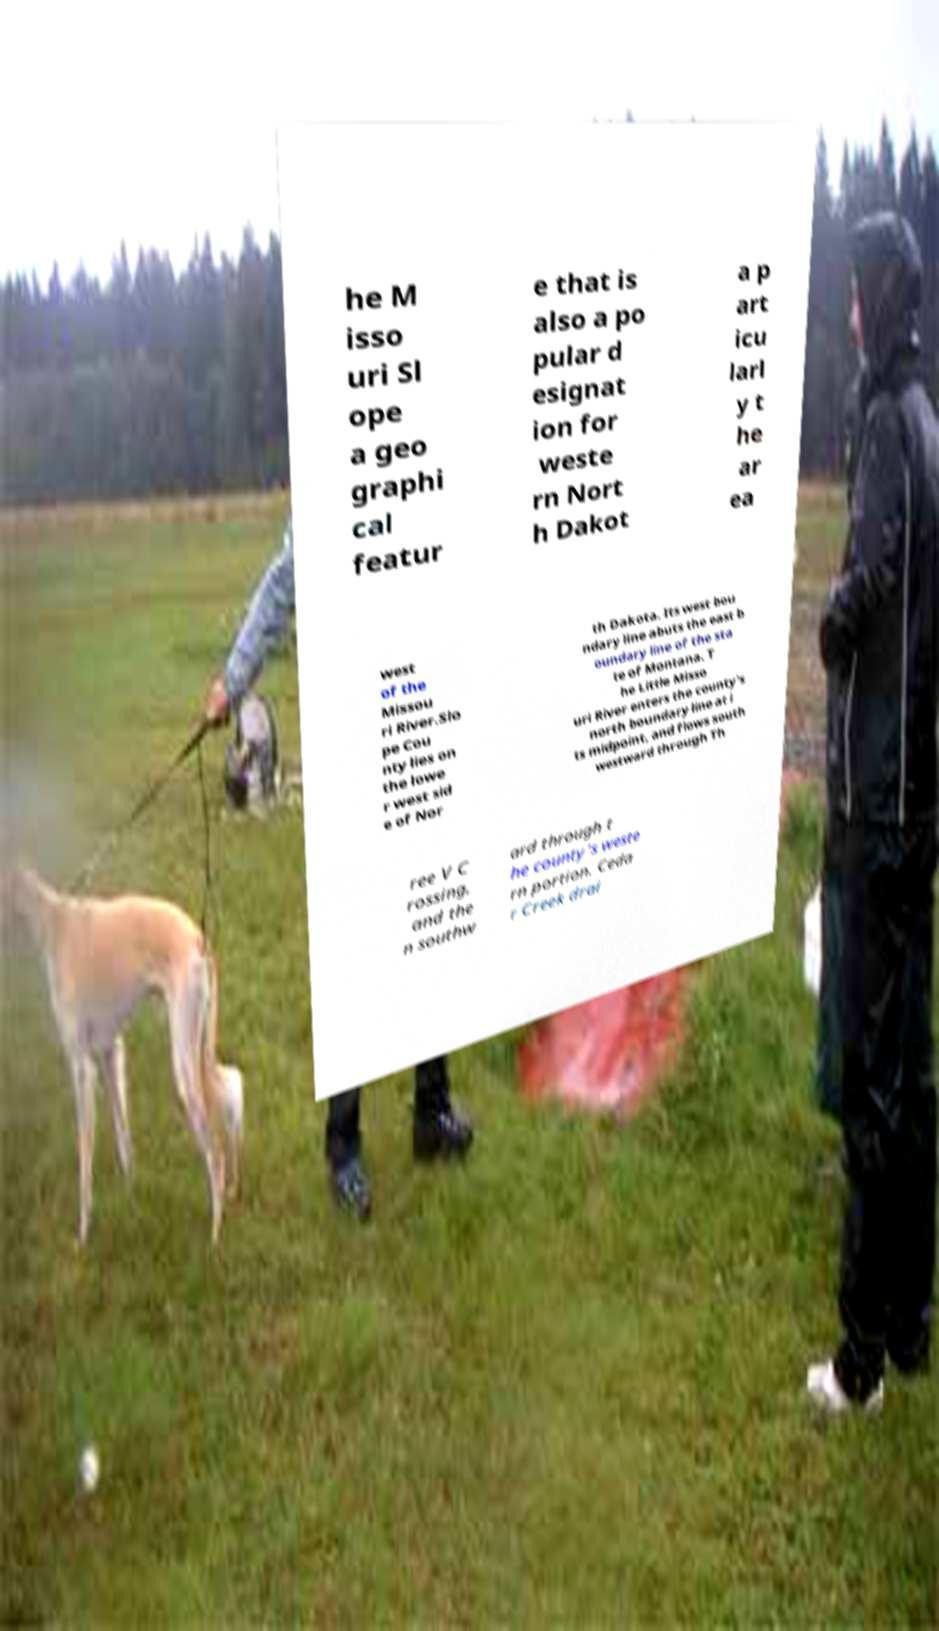I need the written content from this picture converted into text. Can you do that? he M isso uri Sl ope a geo graphi cal featur e that is also a po pular d esignat ion for weste rn Nort h Dakot a p art icu larl y t he ar ea west of the Missou ri River.Slo pe Cou nty lies on the lowe r west sid e of Nor th Dakota. Its west bou ndary line abuts the east b oundary line of the sta te of Montana. T he Little Misso uri River enters the county's north boundary line at i ts midpoint, and flows south westward through Th ree V C rossing, and the n southw ard through t he county's weste rn portion. Ceda r Creek drai 